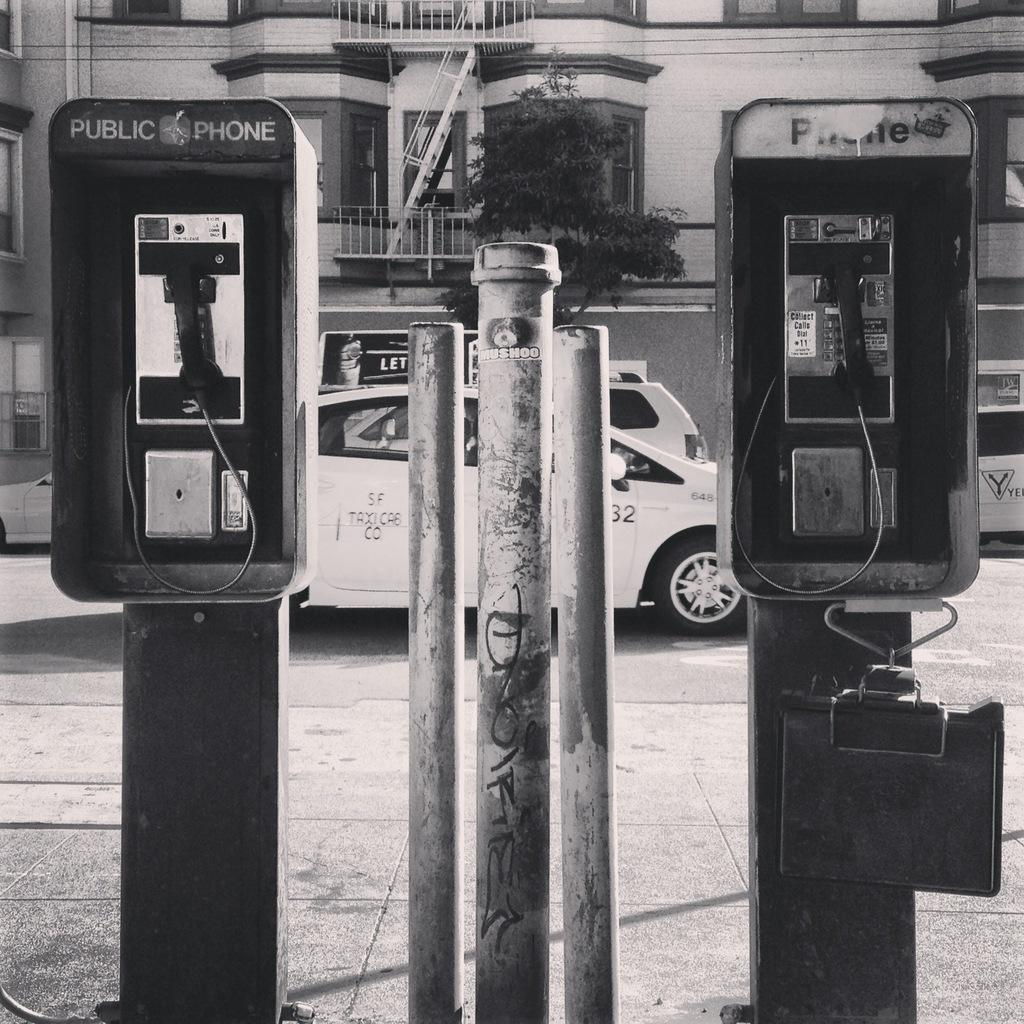<image>
Offer a succinct explanation of the picture presented. Two pay phones are side by side, one is labelled "public phone." 